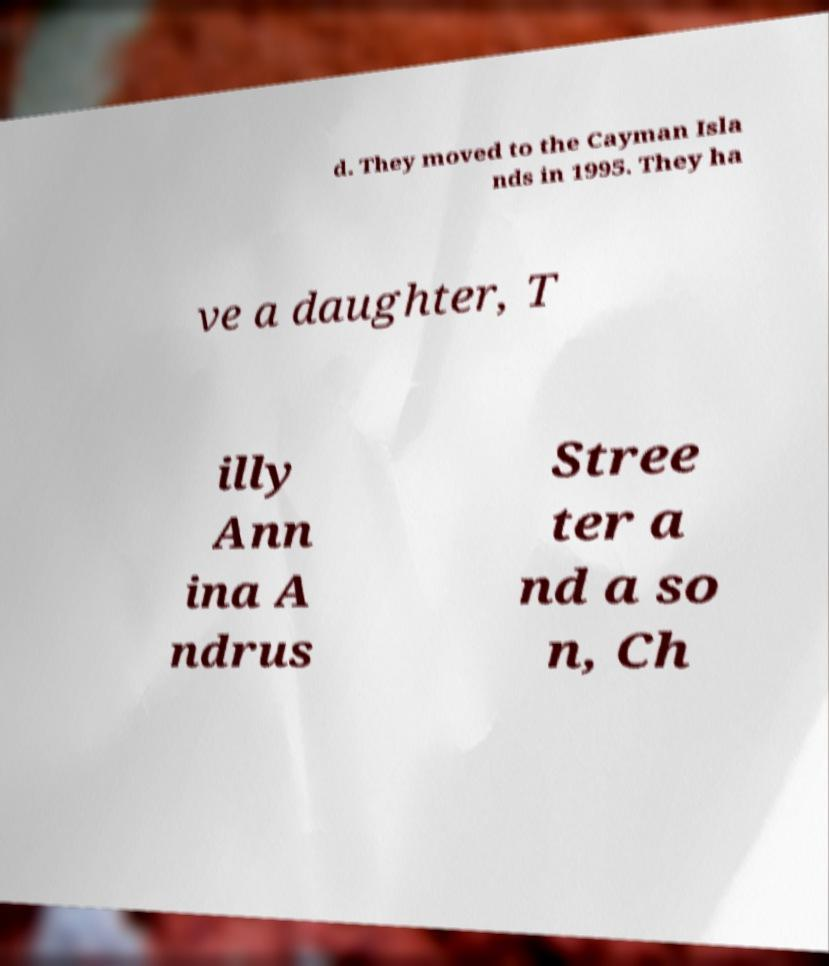For documentation purposes, I need the text within this image transcribed. Could you provide that? d. They moved to the Cayman Isla nds in 1995. They ha ve a daughter, T illy Ann ina A ndrus Stree ter a nd a so n, Ch 